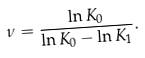Convert formula to latex. <formula><loc_0><loc_0><loc_500><loc_500>\nu = \frac { \ln K _ { 0 } } { \ln K _ { 0 } - \ln K _ { 1 } } .</formula> 